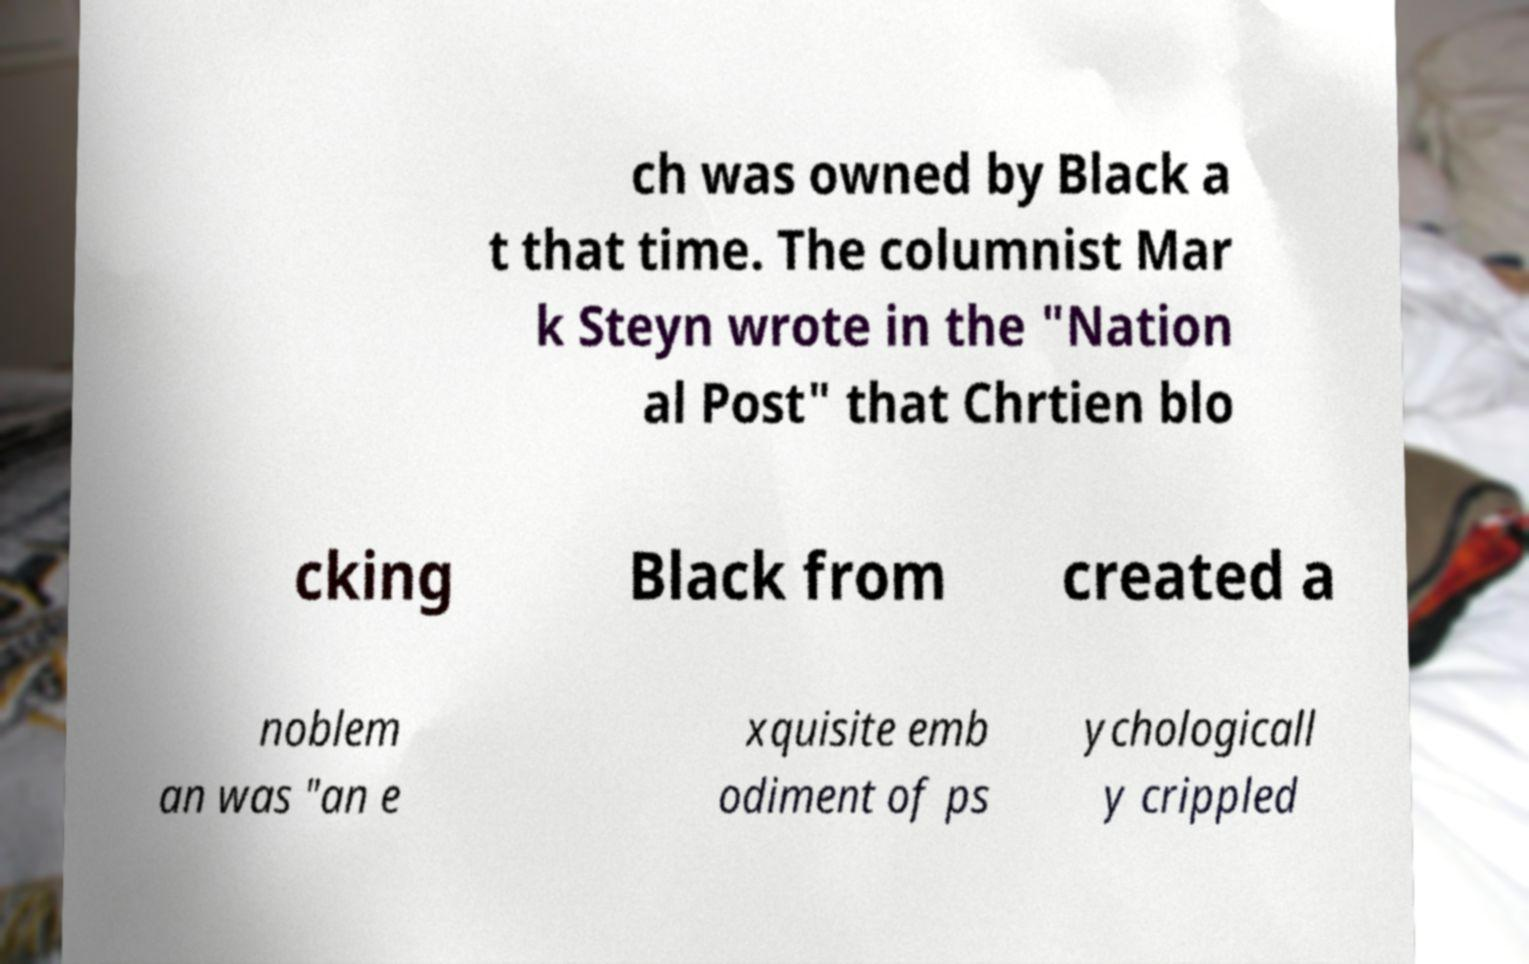What messages or text are displayed in this image? I need them in a readable, typed format. ch was owned by Black a t that time. The columnist Mar k Steyn wrote in the "Nation al Post" that Chrtien blo cking Black from created a noblem an was "an e xquisite emb odiment of ps ychologicall y crippled 